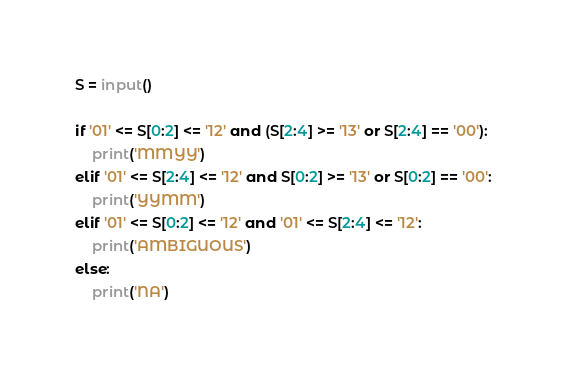<code> <loc_0><loc_0><loc_500><loc_500><_Python_>S = input()

if '01' <= S[0:2] <= '12' and (S[2:4] >= '13' or S[2:4] == '00'):
    print('MMYY')
elif '01' <= S[2:4] <= '12' and S[0:2] >= '13' or S[0:2] == '00':
    print('YYMM')
elif '01' <= S[0:2] <= '12' and '01' <= S[2:4] <= '12':
    print('AMBIGUOUS')
else:
    print('NA')
</code> 